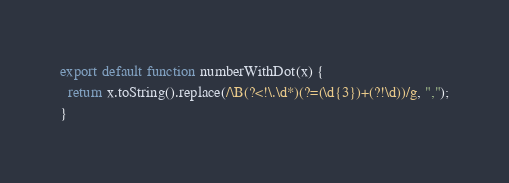Convert code to text. <code><loc_0><loc_0><loc_500><loc_500><_JavaScript_>export default function numberWithDot(x) {
  return x.toString().replace(/\B(?<!\.\d*)(?=(\d{3})+(?!\d))/g, ",");
}
</code> 